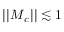Convert formula to latex. <formula><loc_0><loc_0><loc_500><loc_500>| | M _ { c } | | \lesssim 1</formula> 